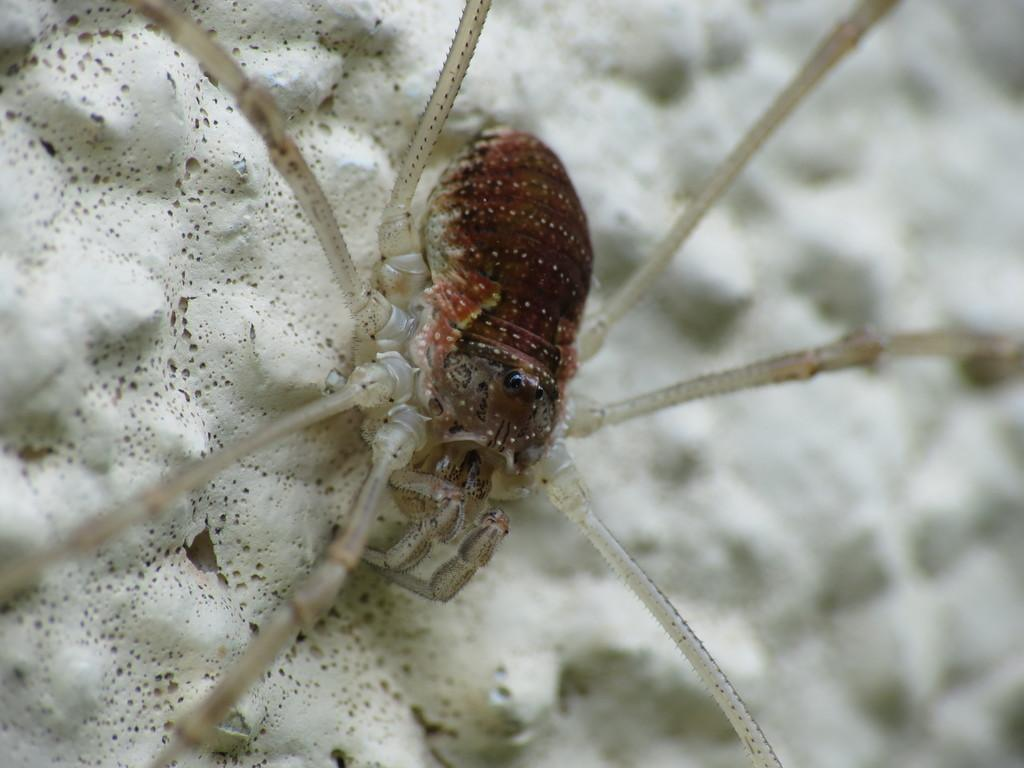What type of creature is present in the picture? There is an insect in the picture. Can you describe the surface on which the insect is present? The insect is present on a white surface. How does the insect react to the son's cry in the image? There is no son or cry present in the image; it only features an insect on a white surface. Is there a tiger visible in the image? No, there is no tiger present in the image. 